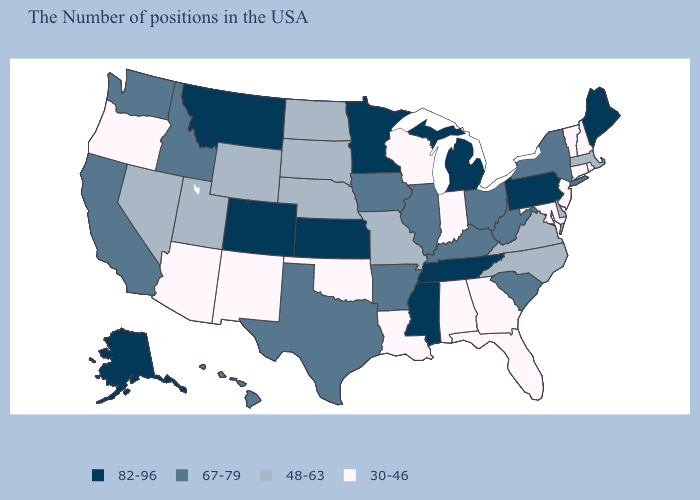What is the lowest value in the MidWest?
Give a very brief answer. 30-46. Does Mississippi have a higher value than Georgia?
Keep it brief. Yes. What is the value of Arkansas?
Keep it brief. 67-79. Which states have the lowest value in the USA?
Short answer required. Rhode Island, New Hampshire, Vermont, Connecticut, New Jersey, Maryland, Florida, Georgia, Indiana, Alabama, Wisconsin, Louisiana, Oklahoma, New Mexico, Arizona, Oregon. Does West Virginia have the lowest value in the South?
Short answer required. No. Is the legend a continuous bar?
Write a very short answer. No. What is the value of Arkansas?
Keep it brief. 67-79. What is the lowest value in the West?
Be succinct. 30-46. Does Mississippi have the highest value in the USA?
Give a very brief answer. Yes. Among the states that border South Carolina , which have the highest value?
Concise answer only. North Carolina. Does Georgia have the lowest value in the South?
Answer briefly. Yes. Name the states that have a value in the range 48-63?
Keep it brief. Massachusetts, Delaware, Virginia, North Carolina, Missouri, Nebraska, South Dakota, North Dakota, Wyoming, Utah, Nevada. What is the highest value in states that border North Carolina?
Write a very short answer. 82-96. Does the map have missing data?
Concise answer only. No. Is the legend a continuous bar?
Keep it brief. No. 